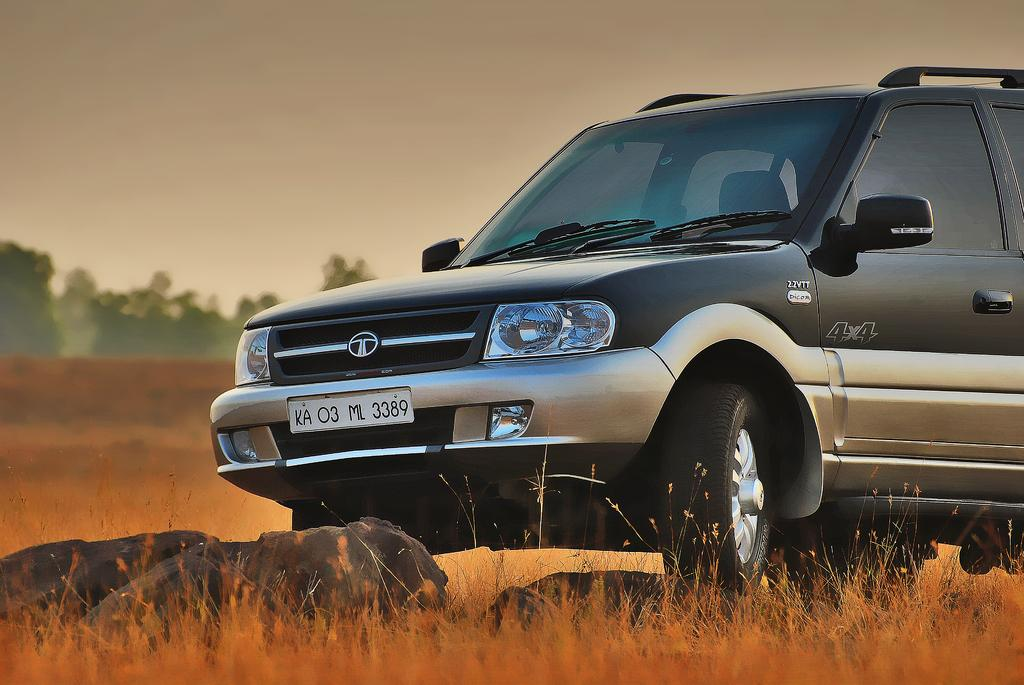What is the main subject of the image? There is a car in the center of the image. Can you describe the car's appearance? The car is black. What can be seen in the background of the image? There is sky, trees, stones, and grass visible in the background of the image. What type of paper is being used to cover the car in the image? There is no paper present in the image, and the car is not covered by any material. Can you tell me how many loaves of bread are visible in the image? There are no loaves of bread present in the image; it features a black car and a background with sky, trees, stones, and grass. 